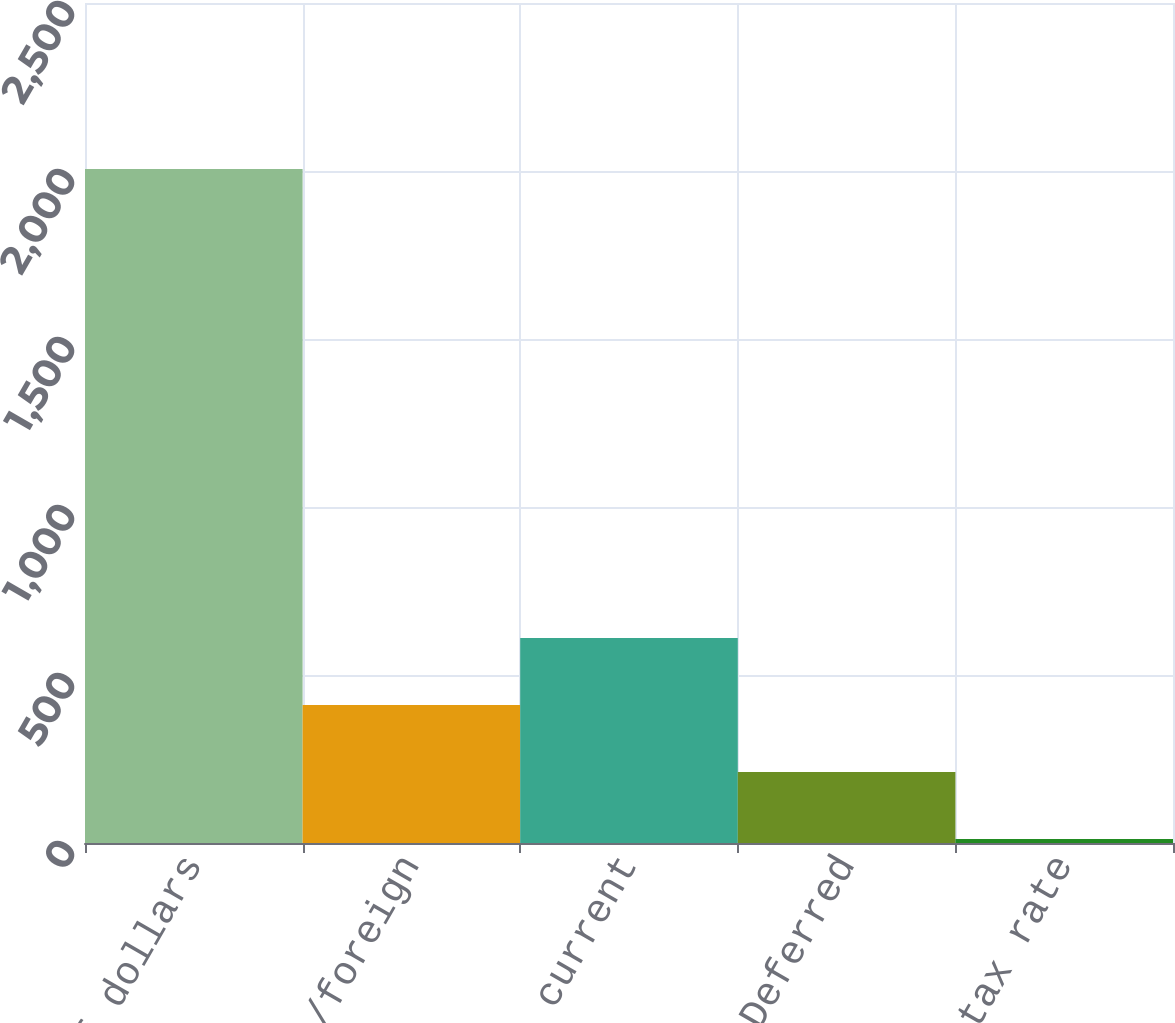Convert chart. <chart><loc_0><loc_0><loc_500><loc_500><bar_chart><fcel>millions of dollars<fcel>Federal/foreign<fcel>Total current<fcel>Deferred<fcel>Effective tax rate<nl><fcel>2006<fcel>410.8<fcel>610.2<fcel>211.4<fcel>12<nl></chart> 